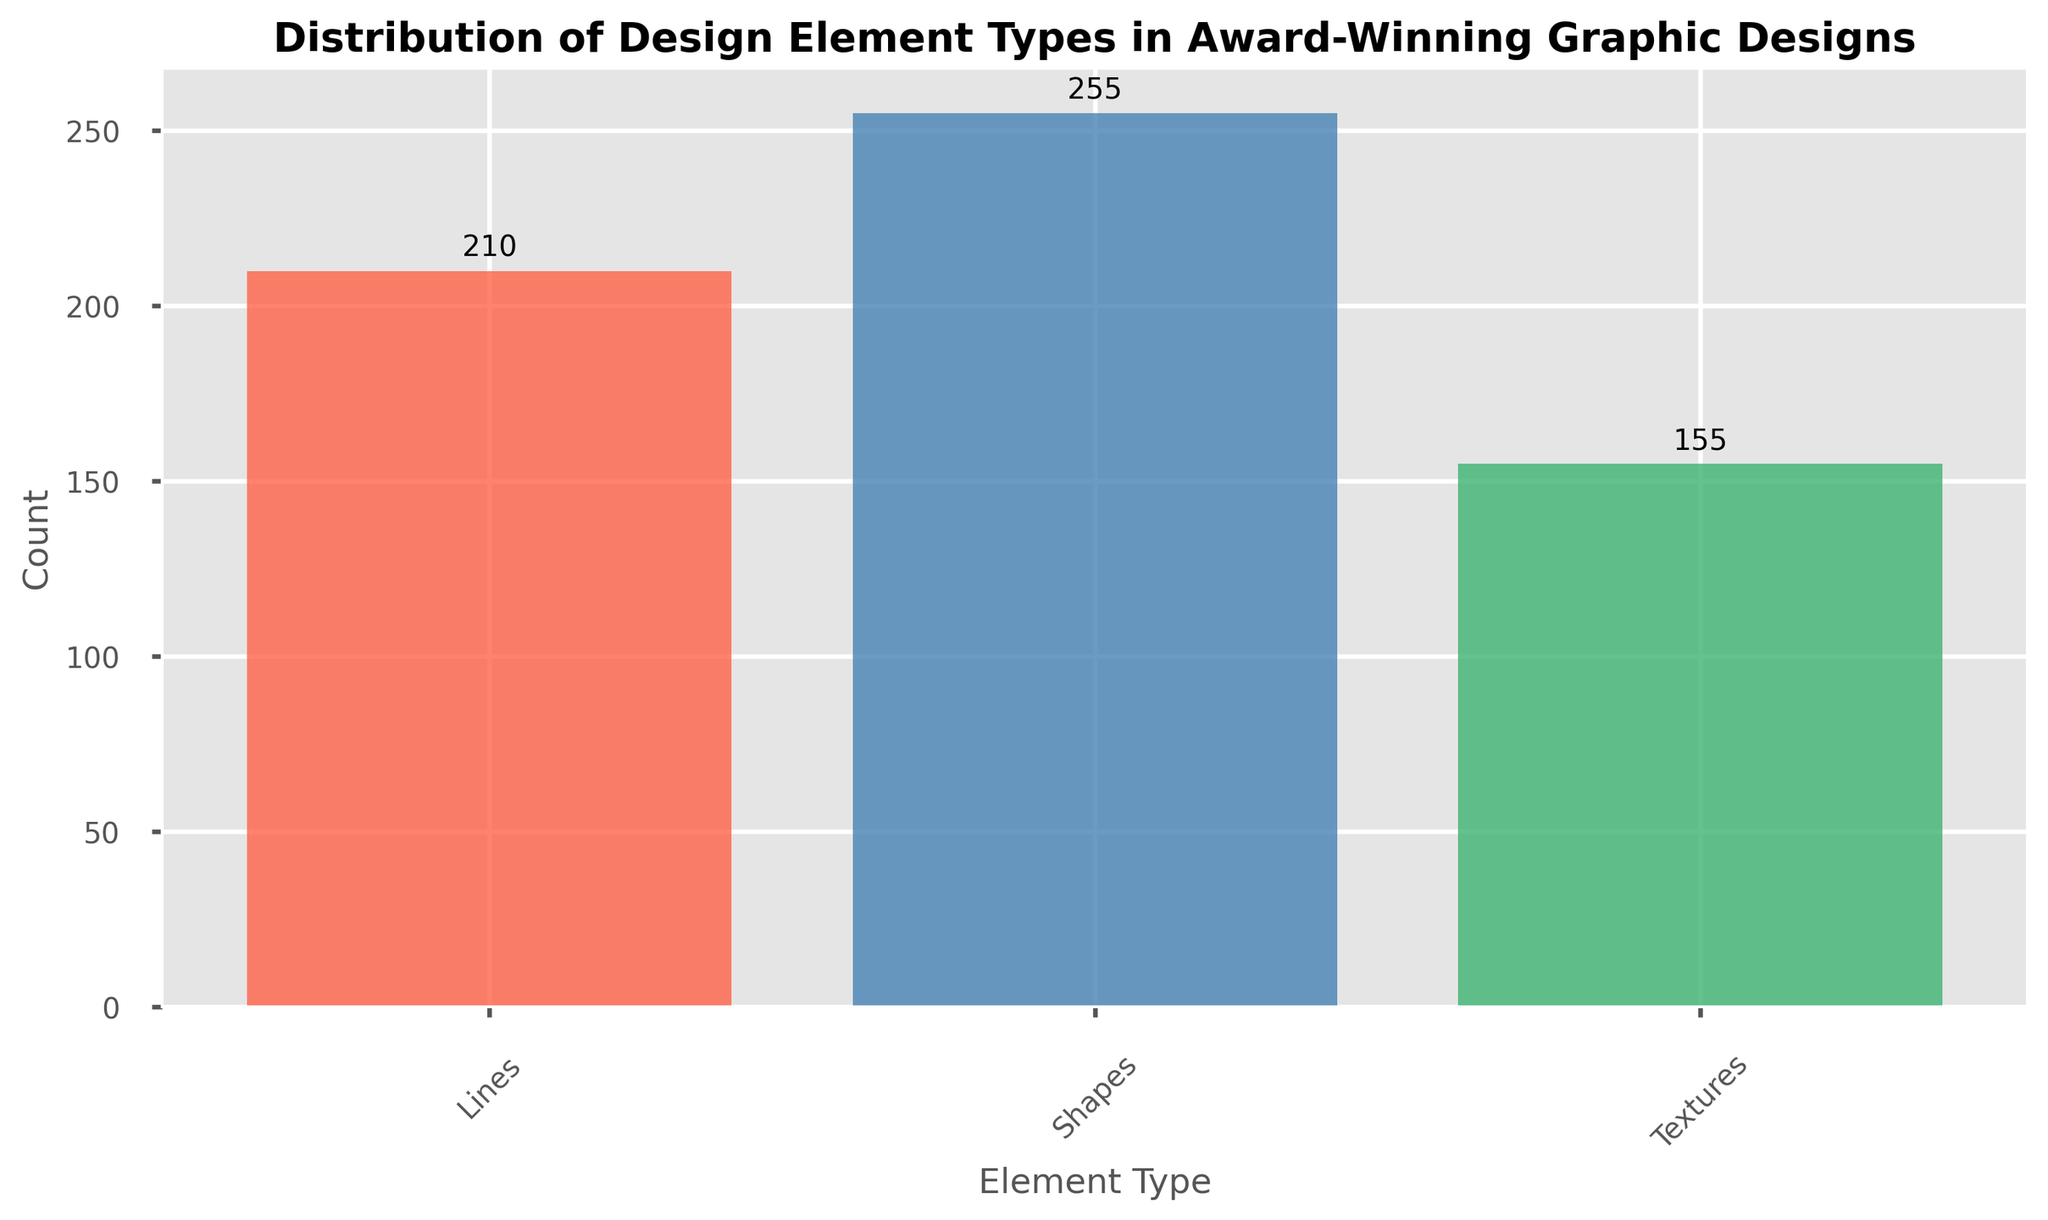What element type has the highest count? To determine the element type with the highest count, look at the heights of the bars. The tallest bar represents the element type with the highest count.
Answer: Shapes Which element type is least represented in the designs? The least represented element type can be found by looking at the shortest bar in the plot.
Answer: Textures What is the total count of Lines in award-winning designs? Add all the values for the element type 'Lines' from the aggregated bars in the plot. The individual values are 15, 20, 30, 25, 20, 35, 40, 25. Summing these values gives: 15 + 20 + 30 + 25 + 20 + 35 + 40 + 25 = 210.
Answer: 210 Compare the total counts of Shapes and Textures. Which one is higher and by how much? First, sum the values for 'Shapes': 25 + 15 + 35 + 30 + 40 + 45 + 35 + 30 = 255. Then, sum the values for 'Textures': 10 + 25 + 20 + 15 + 10 + 25 + 30 + 20 = 155. Shapes have a higher count. Subtract the total count of Textures from Shapes which is 255 - 155 = 100.
Answer: Shapes by 100 What is the average count of Textures across the designs? To find the average count of Textures, first find the total count of Textures which is 155. There are 8 data points for Textures. Calculating the average: 155 / 8 = 19.375.
Answer: 19.375 Which element type has the largest difference in counts compared to another element type? To find this, first note the highest and lowest bars. Shapes have the highest total count: 255. Textures have the lowest total count: 155. The difference is 255 - 155 = 100.
Answer: Shapes and Textures with a difference of 100 How does the count of Lines compare to Shapes in award-winning designs? By comparing the total counts from the aggregated bars, Lines have a total of 210 and Shapes have 255. Thus, Shapes have a higher count than Lines.
Answer: Shapes have a higher count than Lines What is the combined count of Shapes and Textures? Adding the total count for Shapes (255) and Textures (155) gives a combined count: 255 + 155 = 410.
Answer: 410 Between Lines and Textures, which has a higher average count per design? First, sum the totals: Lines = 210, Textures = 155. Both have 8 data points, so the averages are: Lines: 210 / 8 = 26.25, Textures: 155 / 8 = 19.375. Lines have a higher average.
Answer: Lines What is the percentage contribution of Shapes to the total count? Calculate the total count for all elements: 210 (Lines) + 255 (Shapes) + 155 (Textures) = 620. The percentage for Shapes: (255 / 620) * 100 = 41.13%.
Answer: 41.13% 